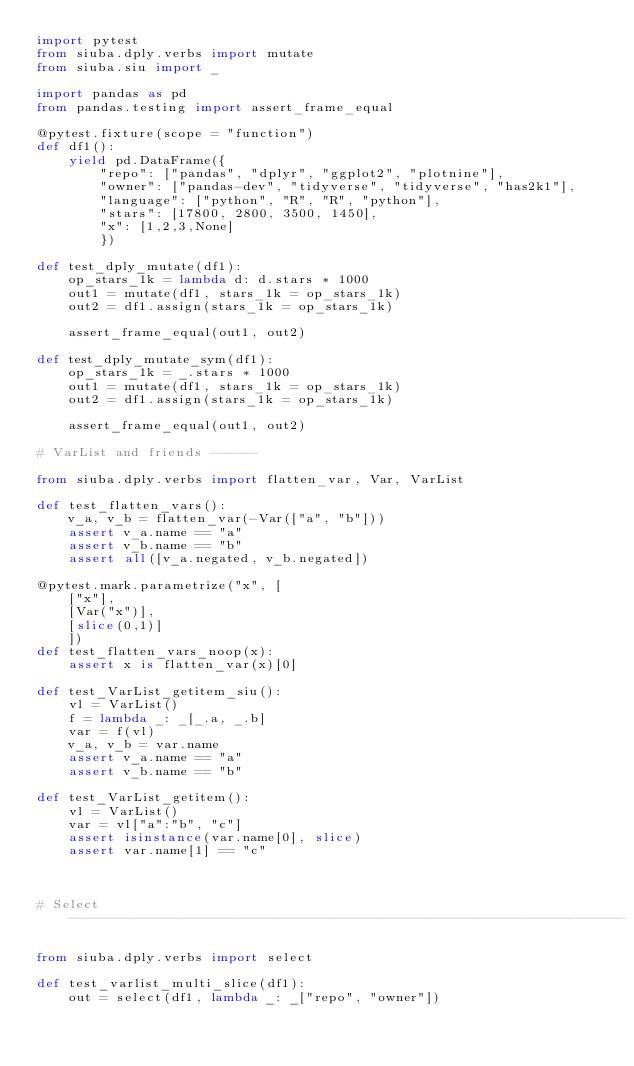Convert code to text. <code><loc_0><loc_0><loc_500><loc_500><_Python_>import pytest
from siuba.dply.verbs import mutate
from siuba.siu import _

import pandas as pd
from pandas.testing import assert_frame_equal

@pytest.fixture(scope = "function")
def df1():
    yield pd.DataFrame({
        "repo": ["pandas", "dplyr", "ggplot2", "plotnine"],
        "owner": ["pandas-dev", "tidyverse", "tidyverse", "has2k1"],
        "language": ["python", "R", "R", "python"],
        "stars": [17800, 2800, 3500, 1450],
        "x": [1,2,3,None]
        })

def test_dply_mutate(df1):
    op_stars_1k = lambda d: d.stars * 1000
    out1 = mutate(df1, stars_1k = op_stars_1k)
    out2 = df1.assign(stars_1k = op_stars_1k)

    assert_frame_equal(out1, out2)

def test_dply_mutate_sym(df1):
    op_stars_1k = _.stars * 1000
    out1 = mutate(df1, stars_1k = op_stars_1k)
    out2 = df1.assign(stars_1k = op_stars_1k)

    assert_frame_equal(out1, out2)

# VarList and friends ------

from siuba.dply.verbs import flatten_var, Var, VarList

def test_flatten_vars():
    v_a, v_b = flatten_var(-Var(["a", "b"]))
    assert v_a.name == "a"
    assert v_b.name == "b"
    assert all([v_a.negated, v_b.negated])

@pytest.mark.parametrize("x", [
    ["x"],
    [Var("x")],
    [slice(0,1)]
    ])
def test_flatten_vars_noop(x):
    assert x is flatten_var(x)[0]

def test_VarList_getitem_siu():
    vl = VarList()
    f = lambda _: _[_.a, _.b]
    var = f(vl)
    v_a, v_b = var.name
    assert v_a.name == "a"
    assert v_b.name == "b"

def test_VarList_getitem():
    vl = VarList()
    var = vl["a":"b", "c"]
    assert isinstance(var.name[0], slice)
    assert var.name[1] == "c"



# Select ----------------------------------------------------------------------

from siuba.dply.verbs import select

def test_varlist_multi_slice(df1):
    out = select(df1, lambda _: _["repo", "owner"])</code> 